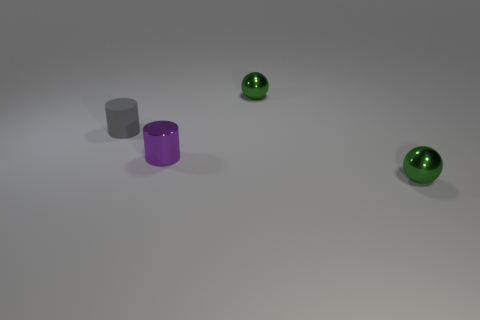There is a cylinder that is the same size as the purple thing; what is its material?
Your response must be concise. Rubber. Is there a ball made of the same material as the purple thing?
Keep it short and to the point. Yes. How many tiny gray matte things are there?
Provide a short and direct response. 1. Do the small purple cylinder and the small green ball in front of the small gray thing have the same material?
Your answer should be compact. Yes. What is the size of the gray cylinder?
Offer a very short reply. Small. Do the gray matte thing and the purple metallic object in front of the small gray rubber cylinder have the same shape?
Offer a terse response. Yes. Are there fewer green things in front of the small gray rubber object than small green shiny things?
Your answer should be compact. Yes. Are there fewer tiny gray things than small balls?
Offer a very short reply. Yes. There is a metal ball in front of the purple object that is in front of the tiny rubber cylinder; what color is it?
Offer a very short reply. Green. There is a small sphere that is on the left side of the metal ball to the right of the tiny green metal thing behind the gray cylinder; what is it made of?
Offer a very short reply. Metal. 